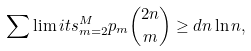<formula> <loc_0><loc_0><loc_500><loc_500>\sum \lim i t s _ { m = 2 } ^ { M } p _ { m } \binom { 2 n } { m } \geq { d n \ln n } ,</formula> 